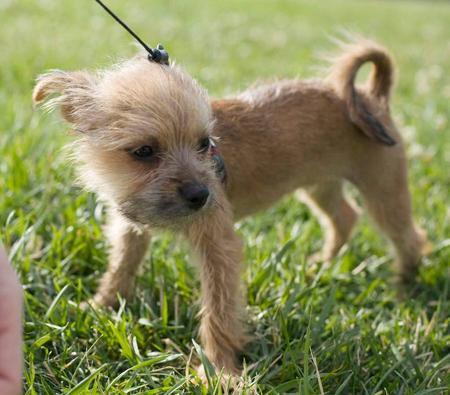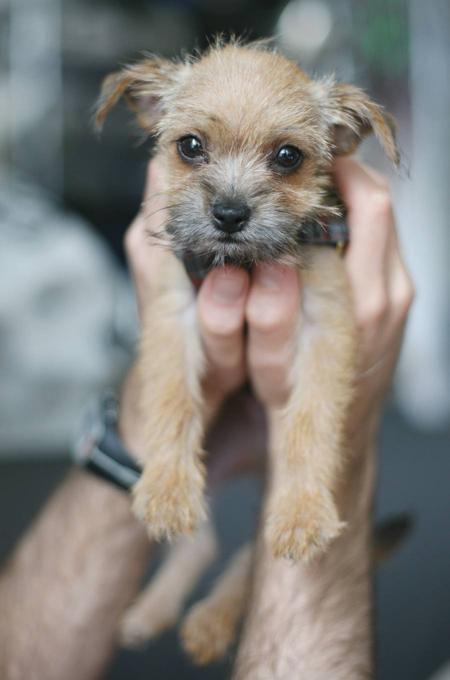The first image is the image on the left, the second image is the image on the right. Considering the images on both sides, is "A medallion can be seen hanging from the collar of the dog in the image on the left." valid? Answer yes or no. No. 